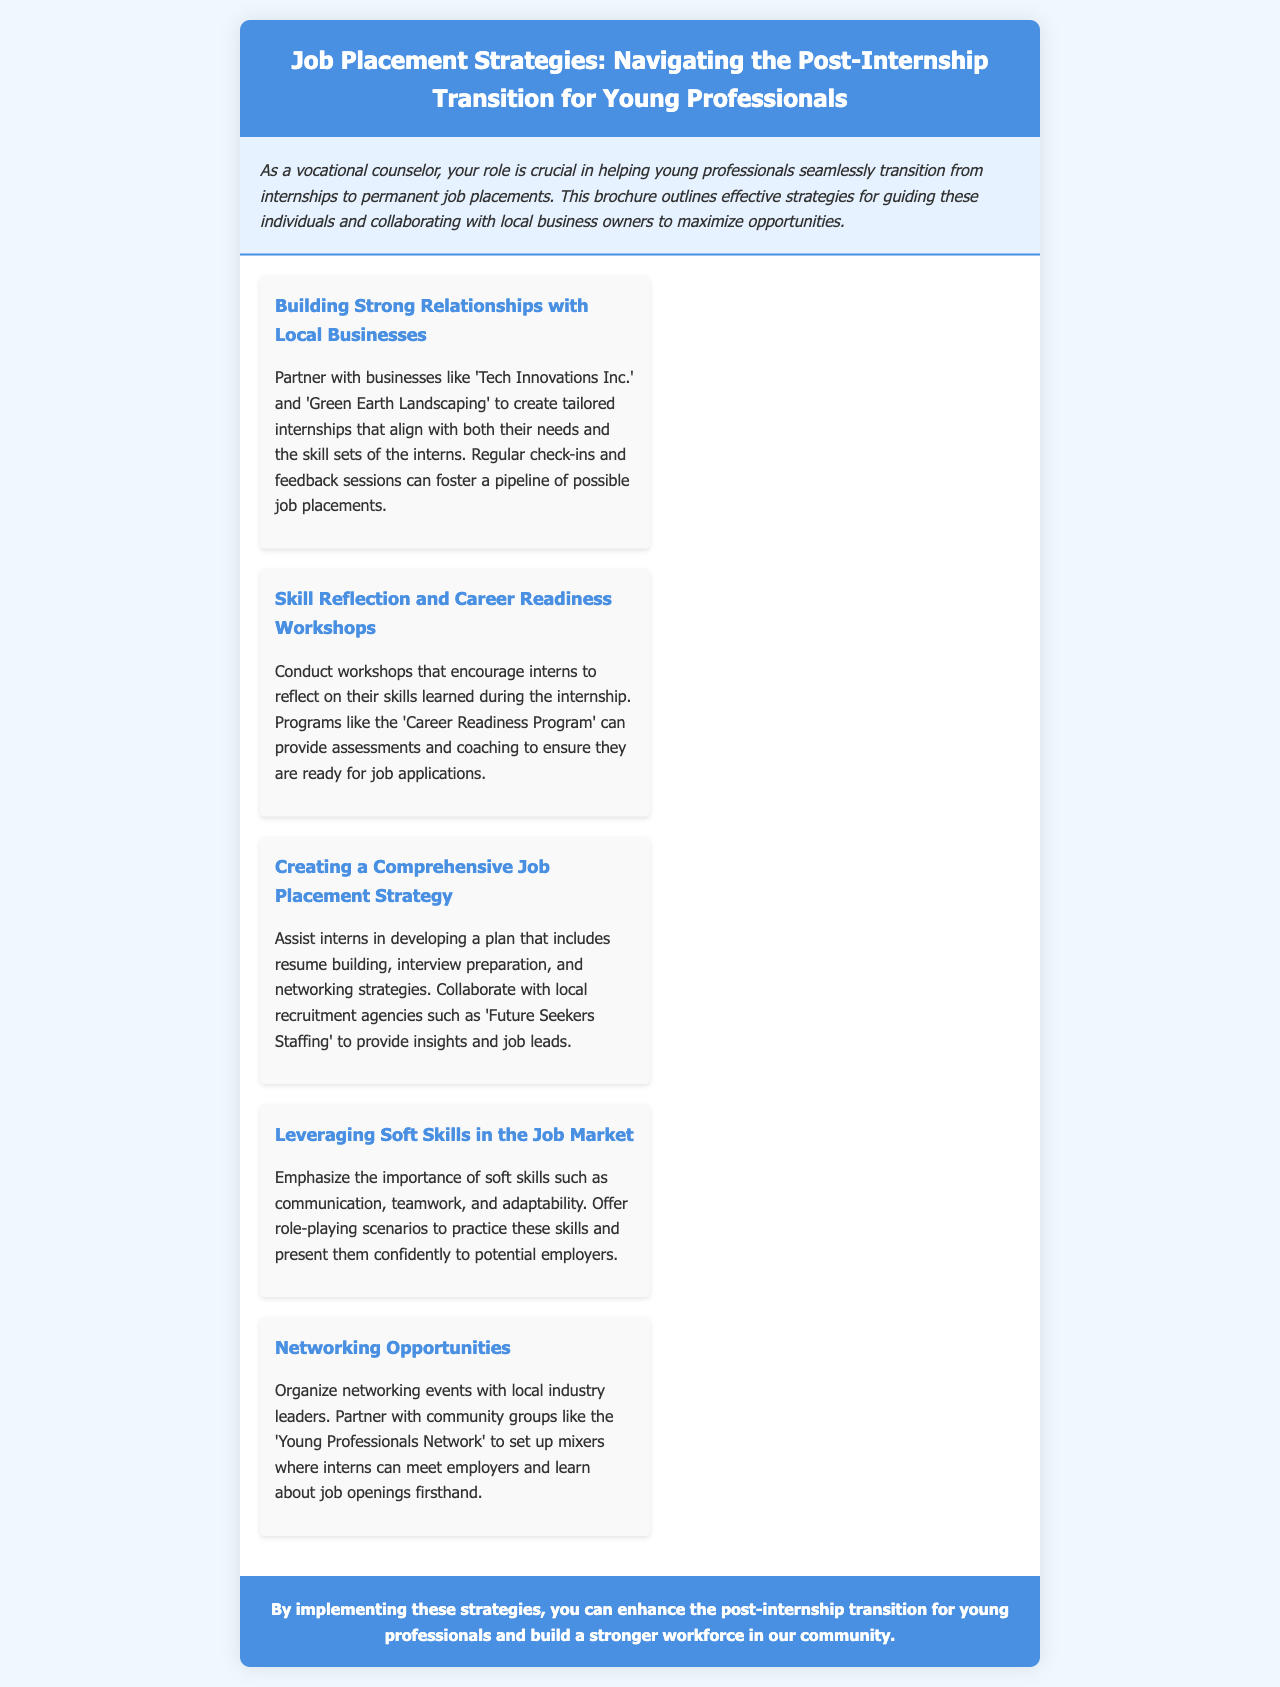What is the title of the brochure? The title is stated clearly at the top of the document.
Answer: Job Placement Strategies: Navigating the Post-Internship Transition for Young Professionals Which companies are mentioned as potential partners for creating internships? The document lists specific businesses that can be partnered with for tailored internships.
Answer: Tech Innovations Inc. and Green Earth Landscaping What is one workshop mentioned for interns? The brochure outlines workshops aimed at skill reflection and career readiness for interns.
Answer: Career Readiness Program What soft skills are emphasized in the document? The document highlights important skills that interns need to focus on to be successful in job applications.
Answer: Communication, teamwork, and adaptability What kind of events does the brochure suggest organizing for networking? The document suggests organizing specific social events for interns to connect with industry leaders.
Answer: Networking events with local industry leaders 